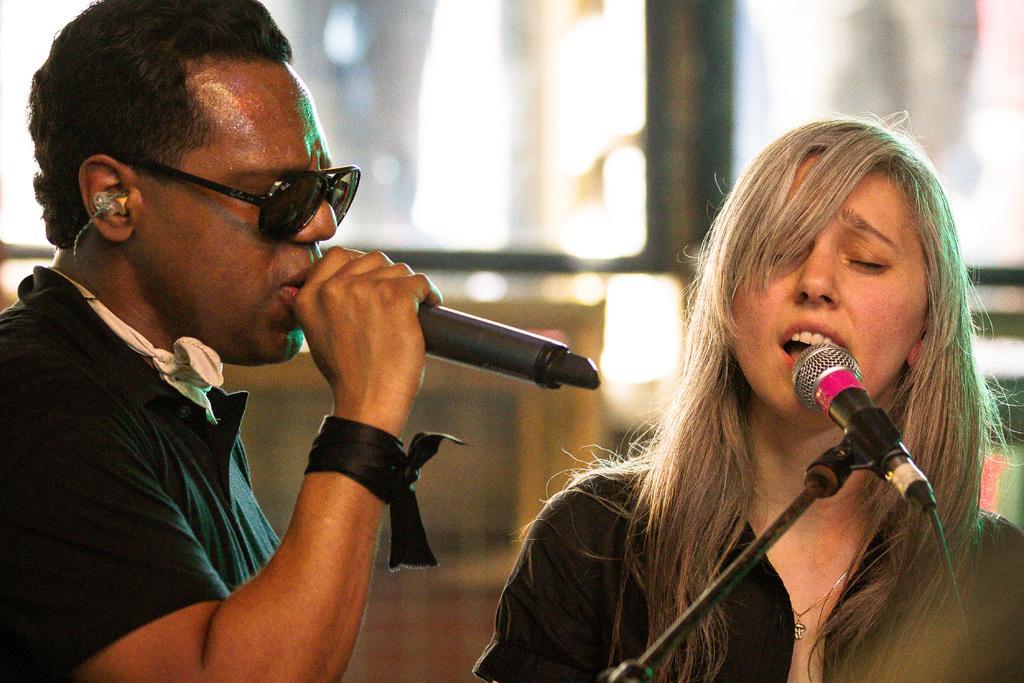In one or two sentences, can you explain what this image depicts? Here we can see two people and the woman in the right is having a microphone and singing in the microphone present in front of her and the man is holding the microphone and singing in the microphone 